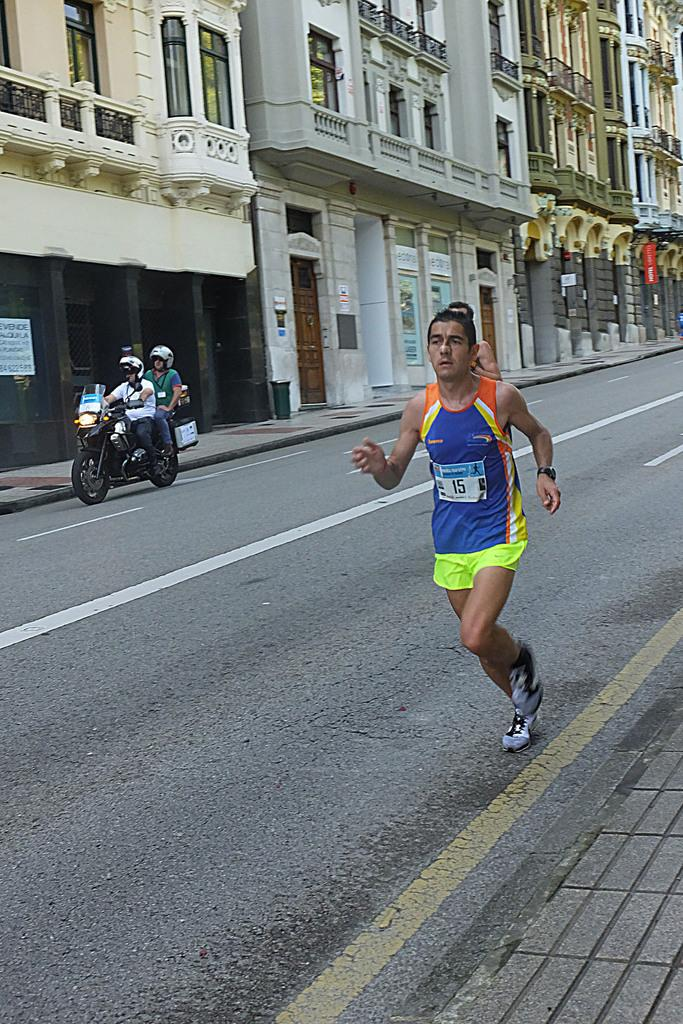What activity is the person in the image engaged in? There is a person riding a bike on the road in the image. What are the other people in the image doing? Two men are running on the same road. What type of structure is visible in the image? There is a building with windows and doors in the image. What additional feature can be seen on the building? There is a banner on the building. Can you see any airplanes taking off or landing at the airport in the image? There is no airport present in the image, so no airplanes can be seen taking off or landing. What type of beetle can be seen crawling on the banner in the image? There are no beetles present in the image; the banner is on a building with no visible insects. 